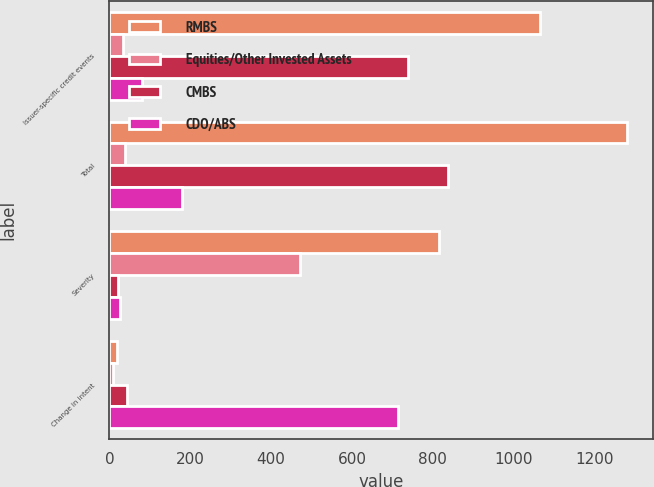<chart> <loc_0><loc_0><loc_500><loc_500><stacked_bar_chart><ecel><fcel>Issuer-specific credit events<fcel>Total<fcel>Severity<fcel>Change in intent<nl><fcel>RMBS<fcel>1066<fcel>1281<fcel>816<fcel>19<nl><fcel>Equities/Other Invested Assets<fcel>34<fcel>39<fcel>471<fcel>8<nl><fcel>CMBS<fcel>739<fcel>838<fcel>21<fcel>44<nl><fcel>CDO/ABS<fcel>81<fcel>179<fcel>26<fcel>715<nl></chart> 